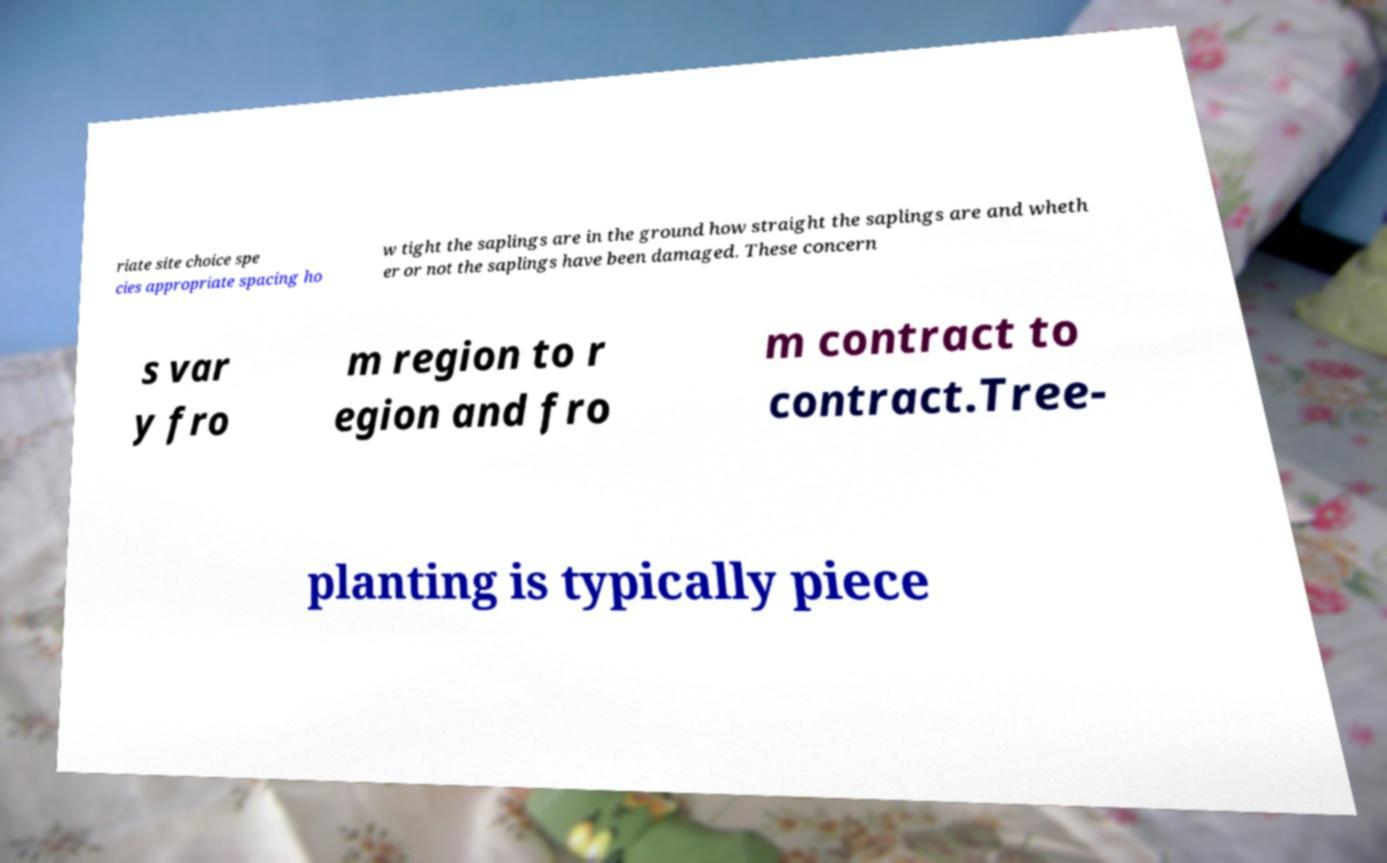Please identify and transcribe the text found in this image. riate site choice spe cies appropriate spacing ho w tight the saplings are in the ground how straight the saplings are and wheth er or not the saplings have been damaged. These concern s var y fro m region to r egion and fro m contract to contract.Tree- planting is typically piece 